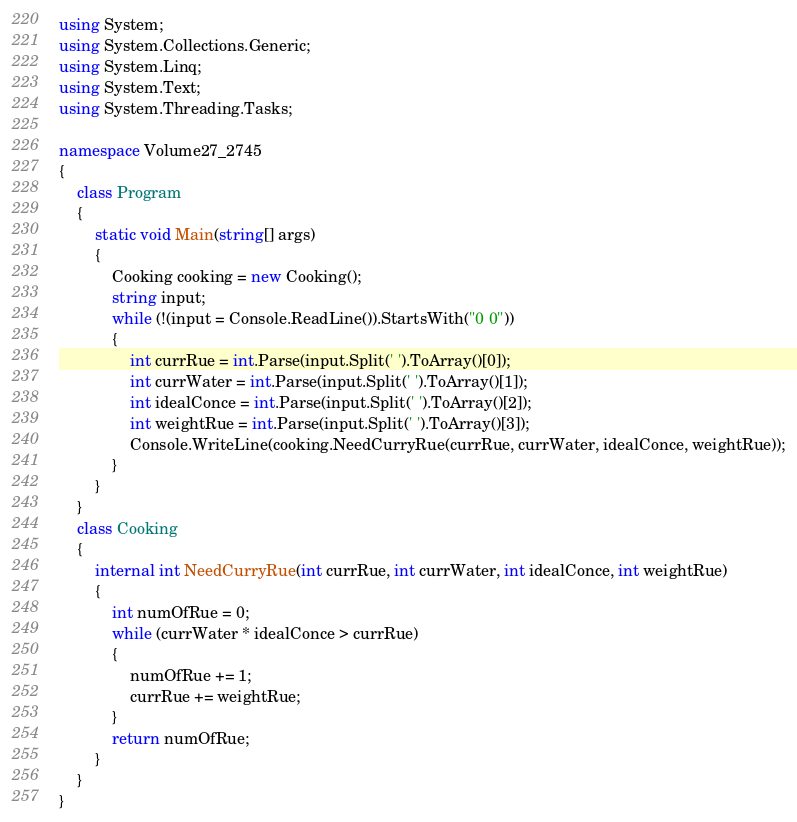<code> <loc_0><loc_0><loc_500><loc_500><_C#_>using System;
using System.Collections.Generic;
using System.Linq;
using System.Text;
using System.Threading.Tasks;

namespace Volume27_2745
{
    class Program
    {
        static void Main(string[] args)
        {
            Cooking cooking = new Cooking();
            string input;
            while (!(input = Console.ReadLine()).StartsWith("0 0"))
            {
                int currRue = int.Parse(input.Split(' ').ToArray()[0]);
                int currWater = int.Parse(input.Split(' ').ToArray()[1]);
                int idealConce = int.Parse(input.Split(' ').ToArray()[2]);
                int weightRue = int.Parse(input.Split(' ').ToArray()[3]);
                Console.WriteLine(cooking.NeedCurryRue(currRue, currWater, idealConce, weightRue));
            }
        }
    }
    class Cooking
    {
        internal int NeedCurryRue(int currRue, int currWater, int idealConce, int weightRue)
        {
            int numOfRue = 0;
            while (currWater * idealConce > currRue)
            {
                numOfRue += 1;
                currRue += weightRue;
            }
            return numOfRue;
        }
    }
}

</code> 